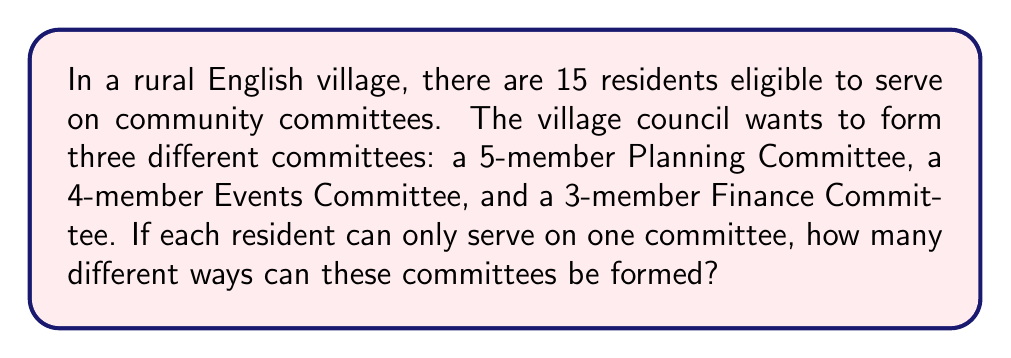Can you solve this math problem? Let's approach this step-by-step using the multiplication principle and combinations:

1) First, we need to choose 5 people for the Planning Committee:
   This can be done in $\binom{15}{5}$ ways.

2) After forming the Planning Committee, we have 10 people left and need to choose 4 for the Events Committee:
   This can be done in $\binom{10}{4}$ ways.

3) Finally, we need to choose 3 people from the remaining 6 for the Finance Committee:
   This can be done in $\binom{6}{3}$ ways.

4) By the multiplication principle, the total number of ways to form these committees is:

   $$\binom{15}{5} \times \binom{10}{4} \times \binom{6}{3}$$

5) Let's calculate each combination:
   
   $\binom{15}{5} = \frac{15!}{5!(15-5)!} = \frac{15!}{5!10!} = 3003$
   
   $\binom{10}{4} = \frac{10!}{4!(10-4)!} = \frac{10!}{4!6!} = 210$
   
   $\binom{6}{3} = \frac{6!}{3!(6-3)!} = \frac{6!}{3!3!} = 20$

6) Multiplying these together:

   $3003 \times 210 \times 20 = 12,612,600$

Therefore, there are 12,612,600 different ways to form these committees.
Answer: 12,612,600 